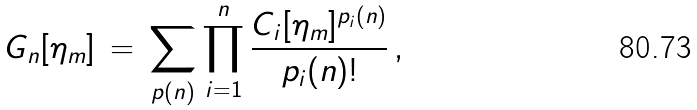Convert formula to latex. <formula><loc_0><loc_0><loc_500><loc_500>G _ { n } [ \eta _ { m } ] \, = \, \sum _ { p ( n ) } \prod _ { i = 1 } ^ { n } \frac { C _ { i } [ \eta _ { m } ] ^ { p _ { i } ( n ) } } { p _ { i } ( n ) ! } \, ,</formula> 